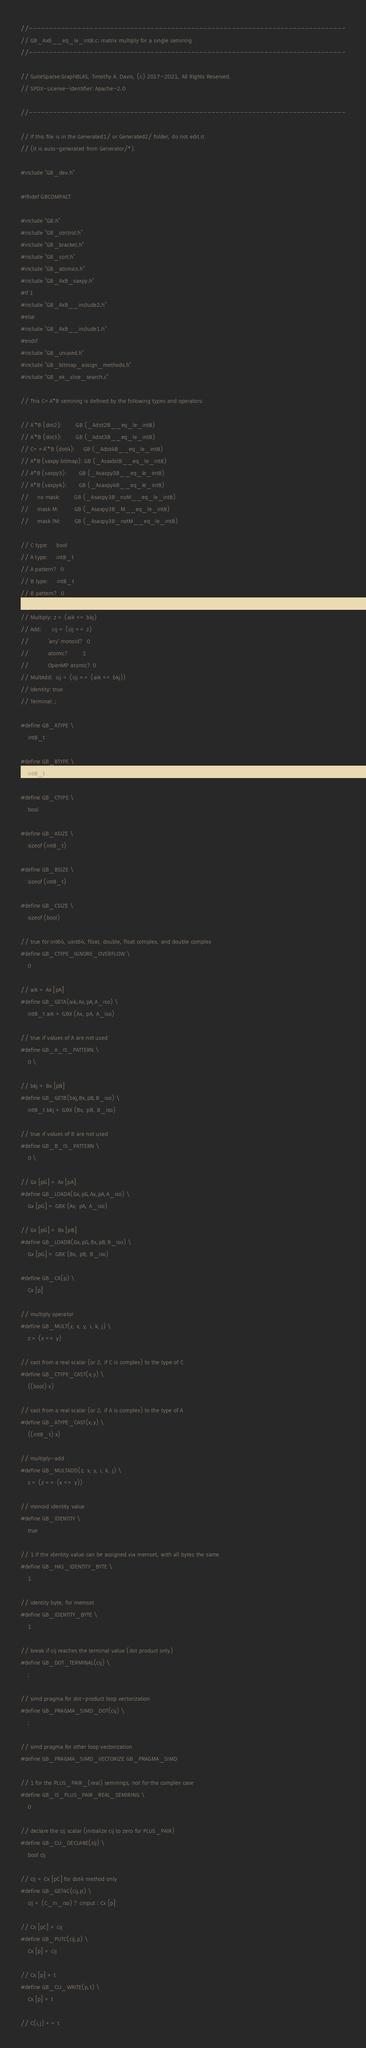<code> <loc_0><loc_0><loc_500><loc_500><_C_>//------------------------------------------------------------------------------
// GB_AxB__eq_le_int8.c: matrix multiply for a single semiring
//------------------------------------------------------------------------------

// SuiteSparse:GraphBLAS, Timothy A. Davis, (c) 2017-2021, All Rights Reserved.
// SPDX-License-Identifier: Apache-2.0

//------------------------------------------------------------------------------

// If this file is in the Generated1/ or Generated2/ folder, do not edit it
// (it is auto-generated from Generator/*).

#include "GB_dev.h"

#ifndef GBCOMPACT

#include "GB.h"
#include "GB_control.h"
#include "GB_bracket.h"
#include "GB_sort.h"
#include "GB_atomics.h"
#include "GB_AxB_saxpy.h"
#if 1
#include "GB_AxB__include2.h"
#else
#include "GB_AxB__include1.h"
#endif
#include "GB_unused.h"
#include "GB_bitmap_assign_methods.h"
#include "GB_ek_slice_search.c"

// This C=A*B semiring is defined by the following types and operators:

// A'*B (dot2):        GB (_Adot2B__eq_le_int8)
// A'*B (dot3):        GB (_Adot3B__eq_le_int8)
// C+=A'*B (dot4):     GB (_Adot4B__eq_le_int8)
// A*B (saxpy bitmap): GB (_AsaxbitB__eq_le_int8)
// A*B (saxpy3):       GB (_Asaxpy3B__eq_le_int8)
// A*B (saxpy4):       GB (_Asaxpy4B__eq_le_int8)
//     no mask:        GB (_Asaxpy3B_noM__eq_le_int8)
//     mask M:         GB (_Asaxpy3B_M__eq_le_int8)
//     mask !M:        GB (_Asaxpy3B_notM__eq_le_int8)

// C type:     bool
// A type:     int8_t
// A pattern?  0
// B type:     int8_t
// B pattern?  0

// Multiply: z = (aik <= bkj)
// Add:      cij = (cij == z)
//           'any' monoid?  0
//           atomic?        1
//           OpenMP atomic? 0
// MultAdd:  cij = (cij == (aik <= bkj))
// Identity: true
// Terminal: ;

#define GB_ATYPE \
    int8_t

#define GB_BTYPE \
    int8_t

#define GB_CTYPE \
    bool

#define GB_ASIZE \
    sizeof (int8_t)

#define GB_BSIZE \
    sizeof (int8_t) 

#define GB_CSIZE \
    sizeof (bool)

// true for int64, uint64, float, double, float complex, and double complex 
#define GB_CTYPE_IGNORE_OVERFLOW \
    0

// aik = Ax [pA]
#define GB_GETA(aik,Ax,pA,A_iso) \
    int8_t aik = GBX (Ax, pA, A_iso)

// true if values of A are not used
#define GB_A_IS_PATTERN \
    0 \

// bkj = Bx [pB]
#define GB_GETB(bkj,Bx,pB,B_iso) \
    int8_t bkj = GBX (Bx, pB, B_iso)

// true if values of B are not used
#define GB_B_IS_PATTERN \
    0 \

// Gx [pG] = Ax [pA]
#define GB_LOADA(Gx,pG,Ax,pA,A_iso) \
    Gx [pG] = GBX (Ax, pA, A_iso)

// Gx [pG] = Bx [pB]
#define GB_LOADB(Gx,pG,Bx,pB,B_iso) \
    Gx [pG] = GBX (Bx, pB, B_iso)

#define GB_CX(p) \
    Cx [p]

// multiply operator
#define GB_MULT(z, x, y, i, k, j) \
    z = (x <= y)

// cast from a real scalar (or 2, if C is complex) to the type of C
#define GB_CTYPE_CAST(x,y) \
    ((bool) x)

// cast from a real scalar (or 2, if A is complex) to the type of A
#define GB_ATYPE_CAST(x,y) \
    ((int8_t) x)

// multiply-add
#define GB_MULTADD(z, x, y, i, k, j) \
    z = (z == (x <= y))

// monoid identity value
#define GB_IDENTITY \
    true

// 1 if the identity value can be assigned via memset, with all bytes the same
#define GB_HAS_IDENTITY_BYTE \
    1

// identity byte, for memset
#define GB_IDENTITY_BYTE \
    1

// break if cij reaches the terminal value (dot product only)
#define GB_DOT_TERMINAL(cij) \
    ;

// simd pragma for dot-product loop vectorization
#define GB_PRAGMA_SIMD_DOT(cij) \
    ;

// simd pragma for other loop vectorization
#define GB_PRAGMA_SIMD_VECTORIZE GB_PRAGMA_SIMD

// 1 for the PLUS_PAIR_(real) semirings, not for the complex case
#define GB_IS_PLUS_PAIR_REAL_SEMIRING \
    0

// declare the cij scalar (initialize cij to zero for PLUS_PAIR)
#define GB_CIJ_DECLARE(cij) \
    bool cij

// cij = Cx [pC] for dot4 method only
#define GB_GET4C(cij,p) \
    cij = (C_in_iso) ? cinput : Cx [p]

// Cx [pC] = cij
#define GB_PUTC(cij,p) \
    Cx [p] = cij

// Cx [p] = t
#define GB_CIJ_WRITE(p,t) \
    Cx [p] = t

// C(i,j) += t</code> 